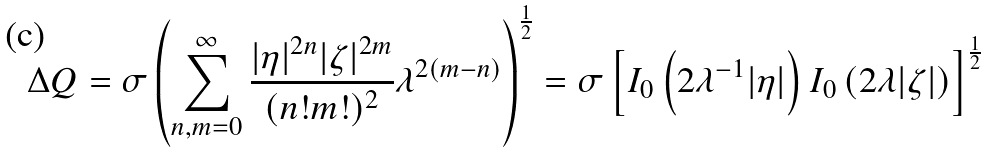Convert formula to latex. <formula><loc_0><loc_0><loc_500><loc_500>\Delta Q = \sigma \left ( \sum _ { n , m = 0 } ^ { \infty } \frac { | \eta | ^ { 2 n } | \zeta | ^ { 2 m } } { ( n ! m ! ) ^ { 2 } } \lambda ^ { 2 ( m - n ) } \right ) ^ { \frac { 1 } { 2 } } = \sigma \left [ I _ { 0 } \left ( 2 \lambda ^ { - 1 } | \eta | \right ) I _ { 0 } \left ( 2 \lambda | \zeta | \right ) \right ] ^ { \frac { 1 } { 2 } }</formula> 